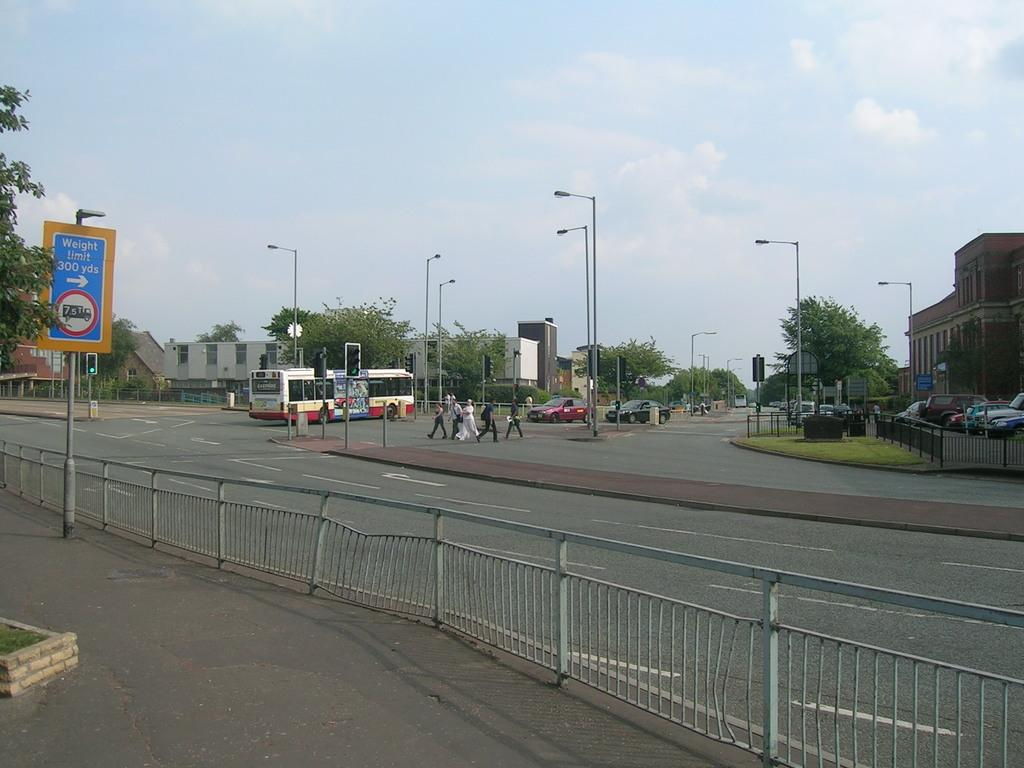<image>
Relay a brief, clear account of the picture shown. A blue and white sign informs motorists of a weight limit on the road. 